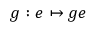<formula> <loc_0><loc_0><loc_500><loc_500>g \colon e \mapsto g e</formula> 